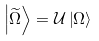<formula> <loc_0><loc_0><loc_500><loc_500>\left | \widetilde { \Omega } \right \rangle = \mathcal { U } \left | \Omega \right \rangle</formula> 